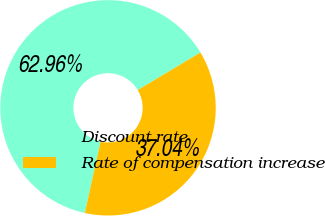Convert chart to OTSL. <chart><loc_0><loc_0><loc_500><loc_500><pie_chart><fcel>Discount rate<fcel>Rate of compensation increase<nl><fcel>62.96%<fcel>37.04%<nl></chart> 